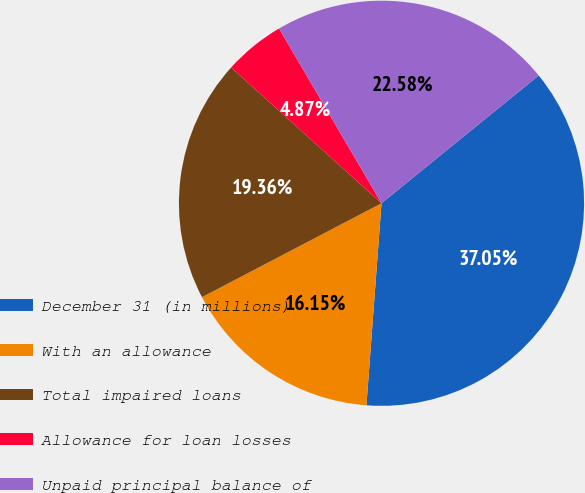Convert chart to OTSL. <chart><loc_0><loc_0><loc_500><loc_500><pie_chart><fcel>December 31 (in millions)<fcel>With an allowance<fcel>Total impaired loans<fcel>Allowance for loan losses<fcel>Unpaid principal balance of<nl><fcel>37.05%<fcel>16.15%<fcel>19.36%<fcel>4.87%<fcel>22.58%<nl></chart> 